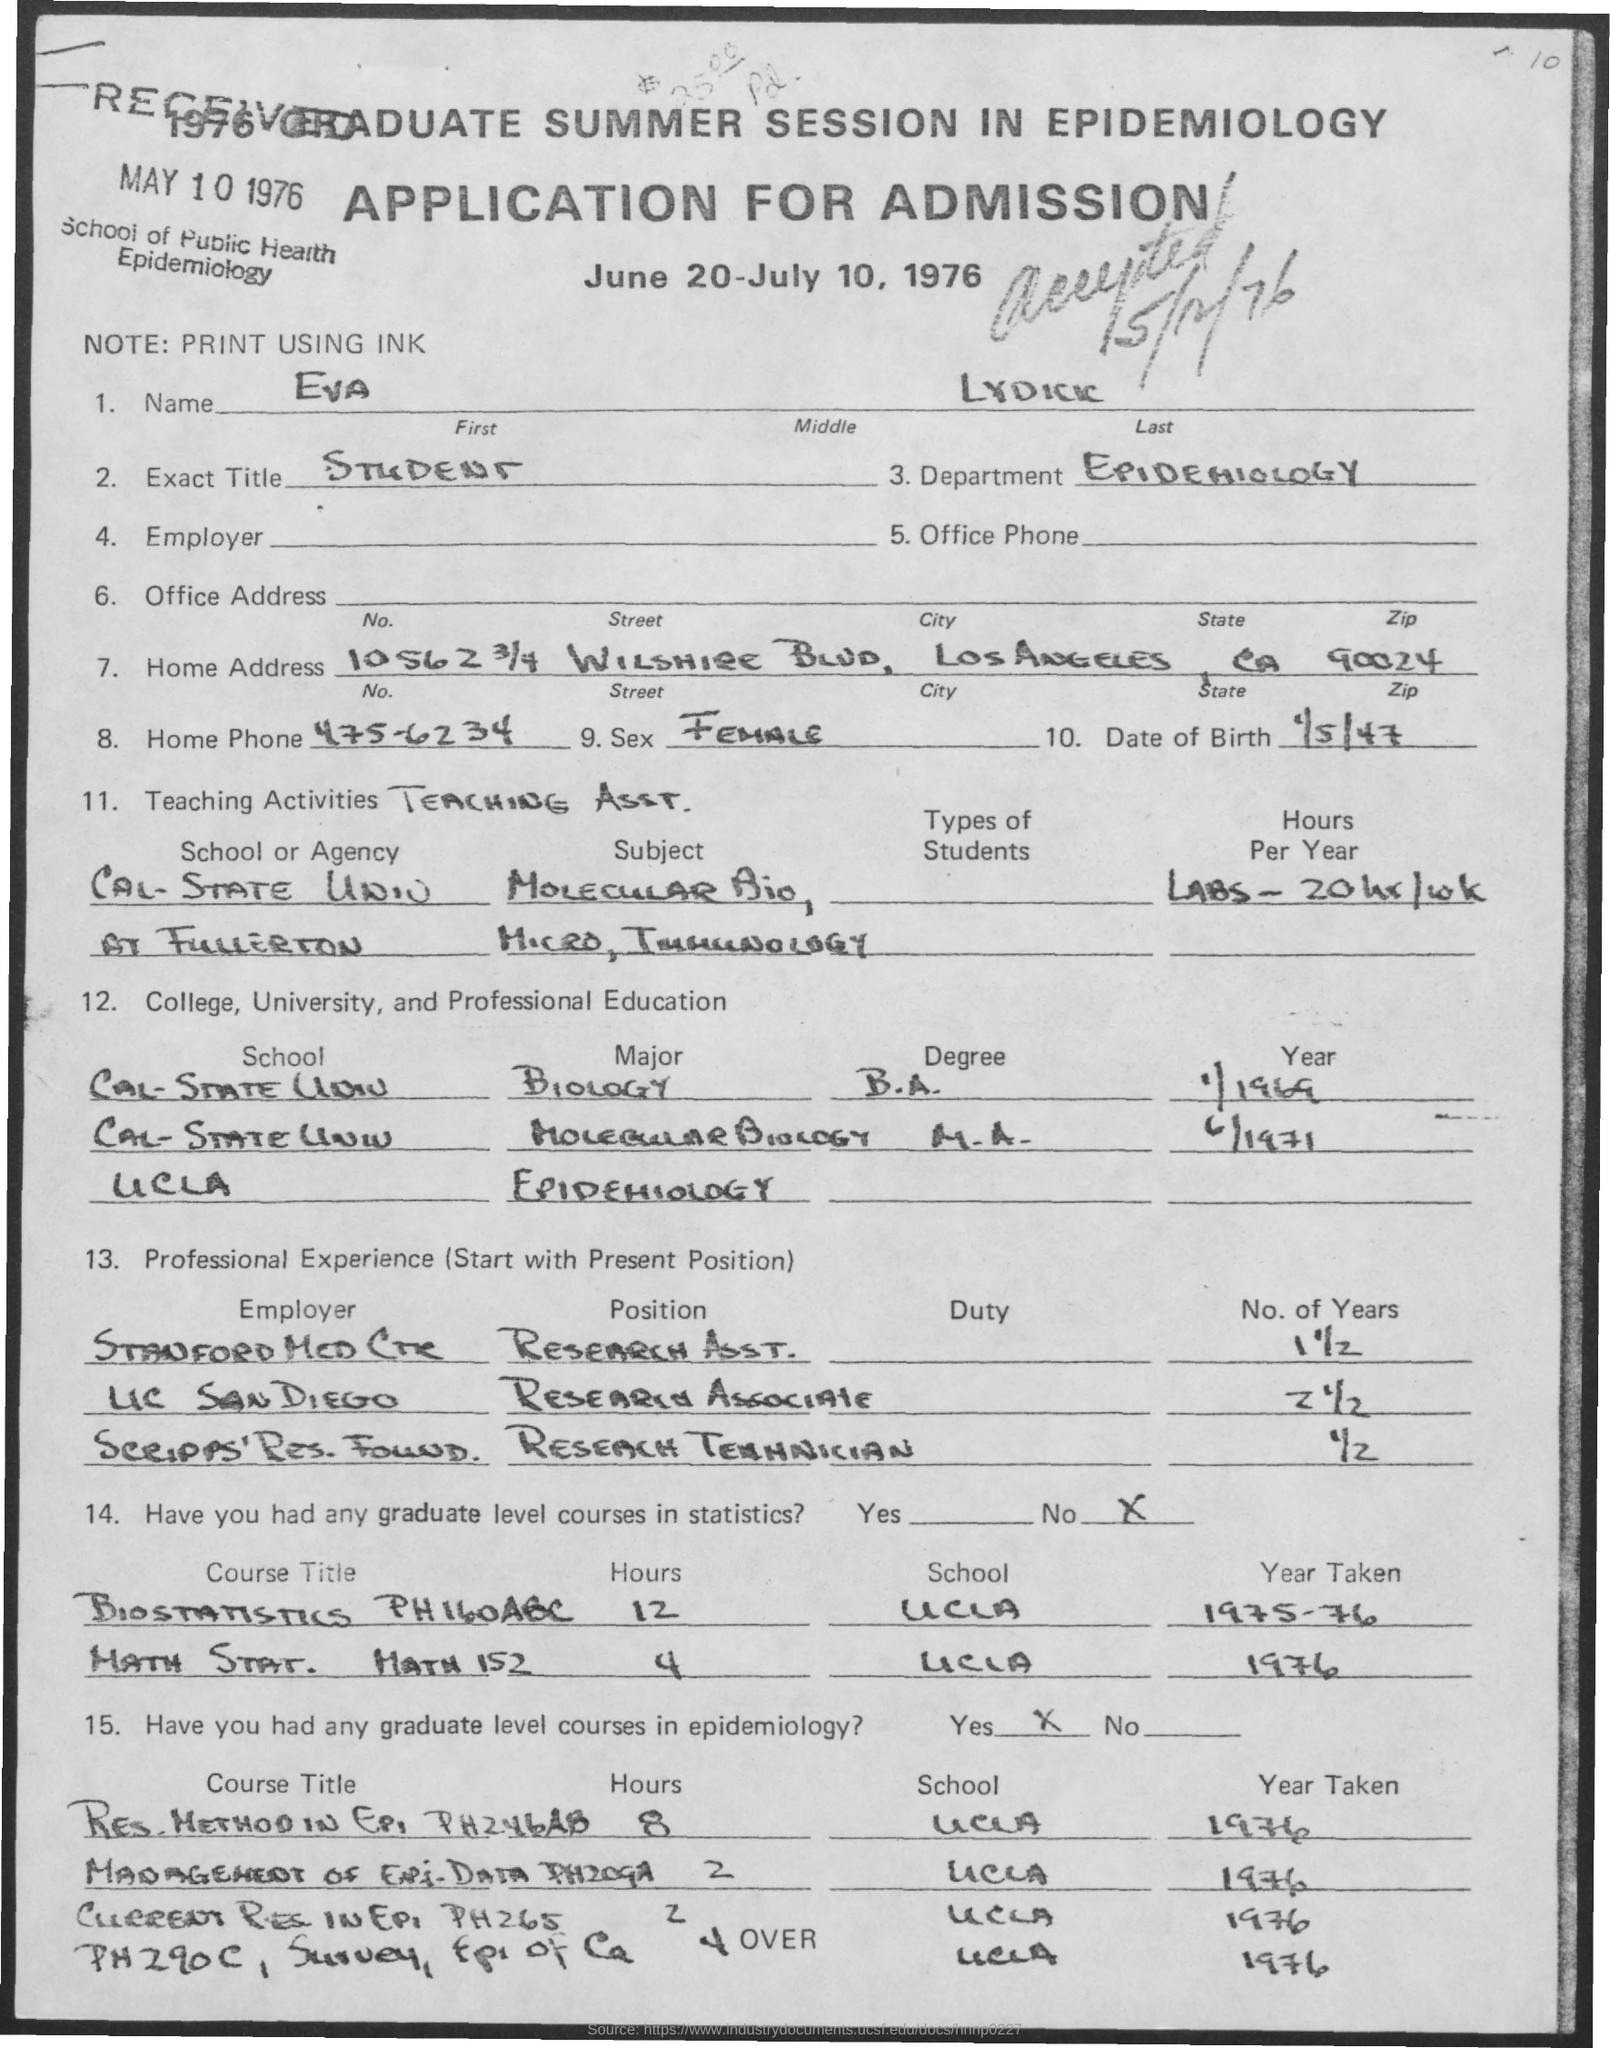What is the First Name?
Offer a very short reply. Eva. When was the Application Received?
Ensure brevity in your answer.  MAY 10 1976. What is the Exact Title?
Your response must be concise. Student. What is the Department?
Provide a succinct answer. Epidemiology. What is the City?
Provide a succinct answer. Los Angeles. What is the State?
Make the answer very short. CA. What is the Zip?
Provide a succinct answer. 90024. What is the Date of Birth?
Provide a succinct answer. 1/5/47. What is the Home Phone?
Offer a very short reply. 475-6234. 